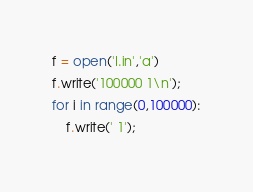<code> <loc_0><loc_0><loc_500><loc_500><_Python_>f = open('I.in','a')
f.write('100000 1\n');
for i in range(0,100000):
    f.write(' 1');
</code> 